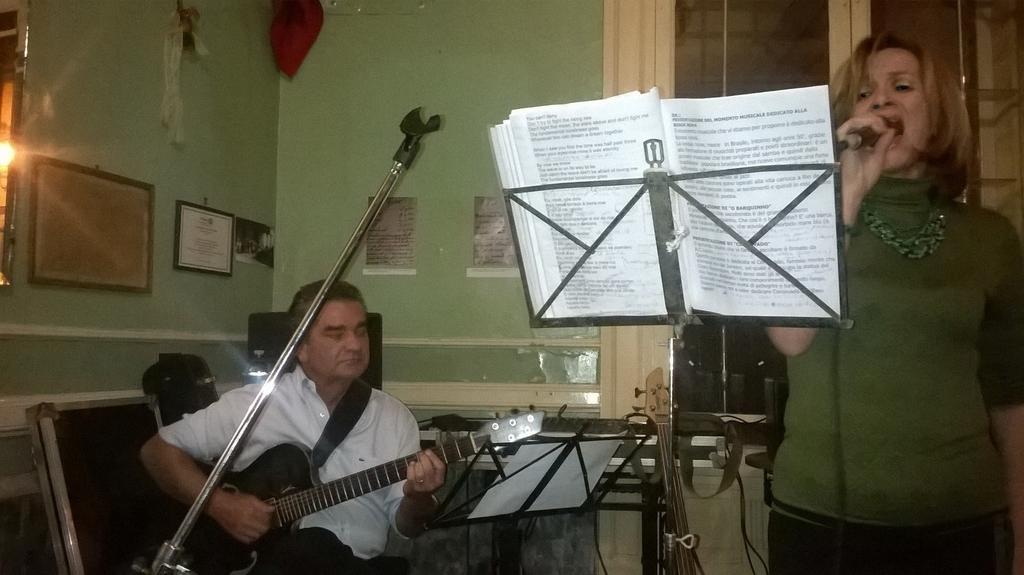What is the person in the image wearing? The person is wearing a green dress in the image. What is the person doing in the image? The person is standing and singing in the image. What is the person using to amplify their voice? The person is in front of a microphone in the image. What is placed in front of the person singing? There is a book stand in front of the person in the image. What is the other person doing in the image? The other person is sitting and playing a guitar beside the person singing in the image. What type of dinner is being served on the table in the image? There is no table or dinner present in the image; it features a person singing and another playing a guitar. What is the income of the person singing in the image? There is no information about the person's income in the image; it only shows them singing and standing in front of a microphone. 